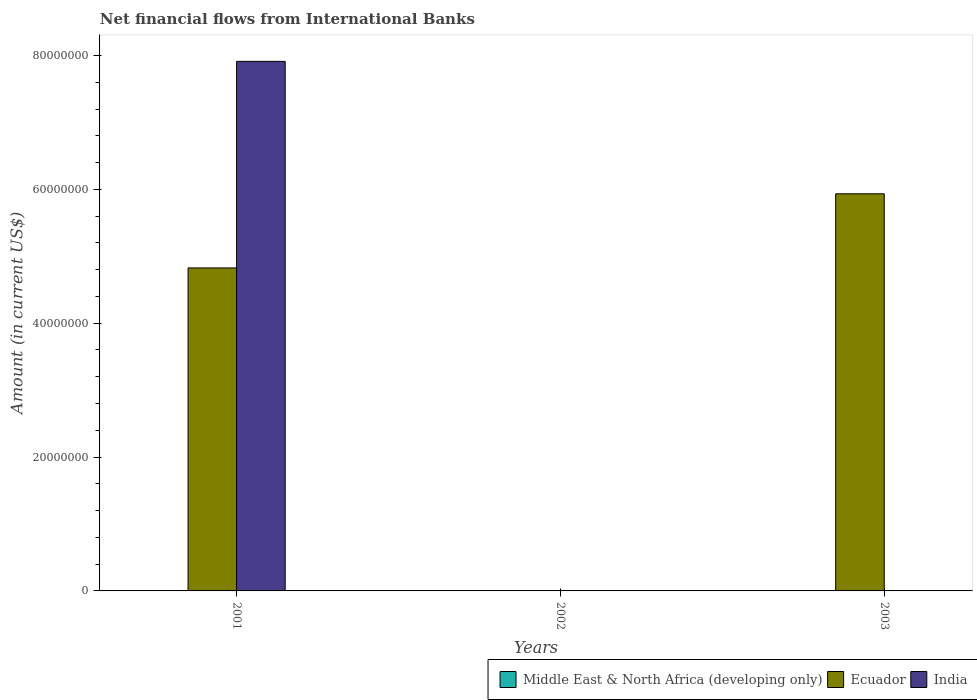Are the number of bars per tick equal to the number of legend labels?
Your answer should be very brief. No. How many bars are there on the 2nd tick from the left?
Give a very brief answer. 0. What is the label of the 1st group of bars from the left?
Ensure brevity in your answer.  2001. In how many cases, is the number of bars for a given year not equal to the number of legend labels?
Your response must be concise. 3. What is the net financial aid flows in India in 2001?
Offer a very short reply. 7.91e+07. Across all years, what is the maximum net financial aid flows in Ecuador?
Ensure brevity in your answer.  5.93e+07. What is the total net financial aid flows in Middle East & North Africa (developing only) in the graph?
Keep it short and to the point. 0. What is the difference between the net financial aid flows in Ecuador in 2001 and that in 2003?
Your answer should be compact. -1.11e+07. What is the difference between the net financial aid flows in Middle East & North Africa (developing only) in 2003 and the net financial aid flows in Ecuador in 2002?
Give a very brief answer. 0. What is the average net financial aid flows in Ecuador per year?
Provide a short and direct response. 3.59e+07. In the year 2001, what is the difference between the net financial aid flows in Ecuador and net financial aid flows in India?
Offer a terse response. -3.09e+07. In how many years, is the net financial aid flows in Ecuador greater than 44000000 US$?
Keep it short and to the point. 2. Is the net financial aid flows in Ecuador in 2001 less than that in 2003?
Offer a very short reply. Yes. What is the difference between the highest and the lowest net financial aid flows in India?
Your answer should be very brief. 7.91e+07. Is the sum of the net financial aid flows in Ecuador in 2001 and 2003 greater than the maximum net financial aid flows in Middle East & North Africa (developing only) across all years?
Make the answer very short. Yes. Is it the case that in every year, the sum of the net financial aid flows in Middle East & North Africa (developing only) and net financial aid flows in Ecuador is greater than the net financial aid flows in India?
Your answer should be compact. No. How many bars are there?
Your answer should be compact. 3. Are all the bars in the graph horizontal?
Provide a succinct answer. No. How many years are there in the graph?
Your answer should be very brief. 3. What is the difference between two consecutive major ticks on the Y-axis?
Offer a very short reply. 2.00e+07. Are the values on the major ticks of Y-axis written in scientific E-notation?
Your answer should be compact. No. Does the graph contain any zero values?
Keep it short and to the point. Yes. Where does the legend appear in the graph?
Your answer should be very brief. Bottom right. How many legend labels are there?
Offer a very short reply. 3. How are the legend labels stacked?
Your response must be concise. Horizontal. What is the title of the graph?
Offer a terse response. Net financial flows from International Banks. Does "Kuwait" appear as one of the legend labels in the graph?
Keep it short and to the point. No. What is the Amount (in current US$) in Ecuador in 2001?
Provide a succinct answer. 4.83e+07. What is the Amount (in current US$) in India in 2001?
Provide a succinct answer. 7.91e+07. What is the Amount (in current US$) in Middle East & North Africa (developing only) in 2002?
Make the answer very short. 0. What is the Amount (in current US$) of Ecuador in 2002?
Give a very brief answer. 0. What is the Amount (in current US$) in India in 2002?
Make the answer very short. 0. What is the Amount (in current US$) in Ecuador in 2003?
Offer a very short reply. 5.93e+07. Across all years, what is the maximum Amount (in current US$) of Ecuador?
Offer a very short reply. 5.93e+07. Across all years, what is the maximum Amount (in current US$) in India?
Provide a succinct answer. 7.91e+07. Across all years, what is the minimum Amount (in current US$) of India?
Keep it short and to the point. 0. What is the total Amount (in current US$) in Ecuador in the graph?
Provide a succinct answer. 1.08e+08. What is the total Amount (in current US$) of India in the graph?
Ensure brevity in your answer.  7.91e+07. What is the difference between the Amount (in current US$) of Ecuador in 2001 and that in 2003?
Provide a short and direct response. -1.11e+07. What is the average Amount (in current US$) of Middle East & North Africa (developing only) per year?
Your answer should be compact. 0. What is the average Amount (in current US$) of Ecuador per year?
Offer a terse response. 3.59e+07. What is the average Amount (in current US$) of India per year?
Give a very brief answer. 2.64e+07. In the year 2001, what is the difference between the Amount (in current US$) in Ecuador and Amount (in current US$) in India?
Offer a very short reply. -3.09e+07. What is the ratio of the Amount (in current US$) of Ecuador in 2001 to that in 2003?
Offer a very short reply. 0.81. What is the difference between the highest and the lowest Amount (in current US$) in Ecuador?
Provide a short and direct response. 5.93e+07. What is the difference between the highest and the lowest Amount (in current US$) of India?
Your response must be concise. 7.91e+07. 